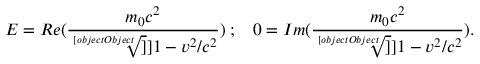Convert formula to latex. <formula><loc_0><loc_0><loc_500><loc_500>E = R e ( \frac { m _ { 0 } c ^ { 2 } } { \sqrt { [ } [ o b j e c t O b j e c t ] ] ] { 1 - v ^ { 2 } / c ^ { 2 } } } ) \, ; \, 0 = I m ( \frac { m _ { 0 } c ^ { 2 } } { \sqrt { [ } [ o b j e c t O b j e c t ] ] ] { 1 - v ^ { 2 } / c ^ { 2 } } } ) .</formula> 